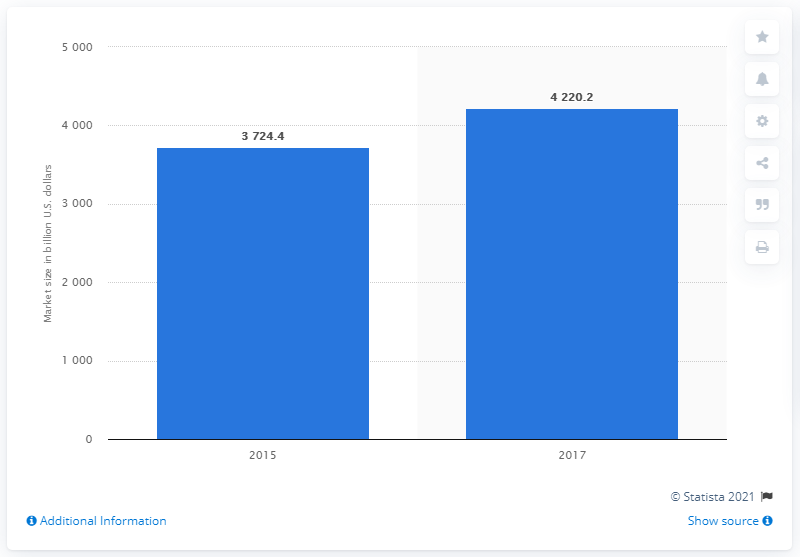Draw attention to some important aspects in this diagram. In 2017, the global wellness industry was worth approximately 42,202.2 million dollars. 